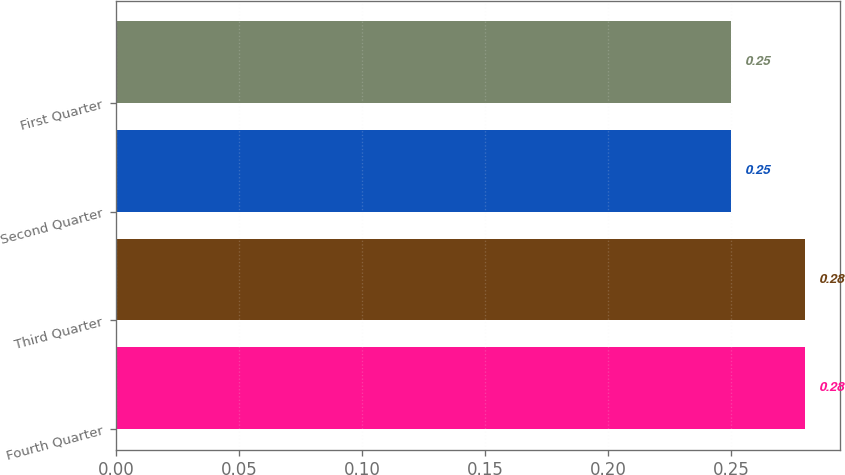Convert chart to OTSL. <chart><loc_0><loc_0><loc_500><loc_500><bar_chart><fcel>Fourth Quarter<fcel>Third Quarter<fcel>Second Quarter<fcel>First Quarter<nl><fcel>0.28<fcel>0.28<fcel>0.25<fcel>0.25<nl></chart> 